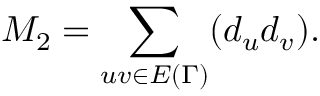Convert formula to latex. <formula><loc_0><loc_0><loc_500><loc_500>M _ { 2 } = \sum _ { u v \in E { ( \Gamma ) } } ( d _ { u } d _ { v } ) .</formula> 